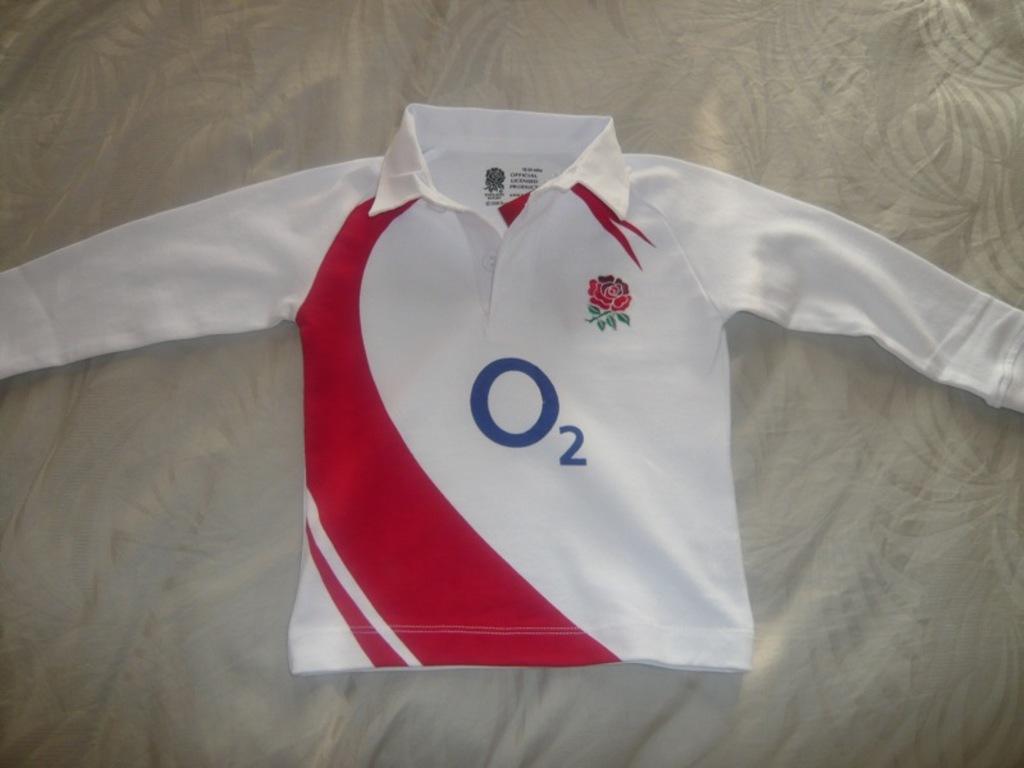What is the chemical element?
Provide a succinct answer. O2. 